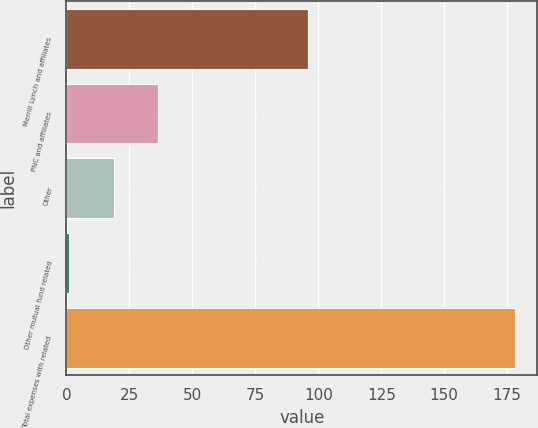<chart> <loc_0><loc_0><loc_500><loc_500><bar_chart><fcel>Merrill Lynch and affiliates<fcel>PNC and affiliates<fcel>Other<fcel>Other mutual fund related<fcel>Total expenses with related<nl><fcel>96<fcel>36.4<fcel>18.7<fcel>1<fcel>178<nl></chart> 